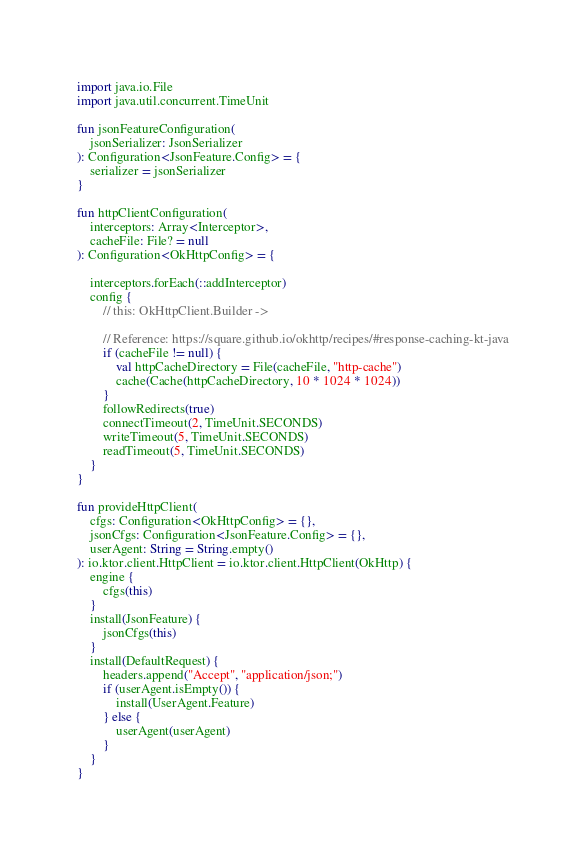Convert code to text. <code><loc_0><loc_0><loc_500><loc_500><_Kotlin_>import java.io.File
import java.util.concurrent.TimeUnit

fun jsonFeatureConfiguration(
    jsonSerializer: JsonSerializer
): Configuration<JsonFeature.Config> = {
    serializer = jsonSerializer
}

fun httpClientConfiguration(
    interceptors: Array<Interceptor>,
    cacheFile: File? = null
): Configuration<OkHttpConfig> = {

    interceptors.forEach(::addInterceptor)
    config {
        // this: OkHttpClient.Builder ->

        // Reference: https://square.github.io/okhttp/recipes/#response-caching-kt-java
        if (cacheFile != null) {
            val httpCacheDirectory = File(cacheFile, "http-cache")
            cache(Cache(httpCacheDirectory, 10 * 1024 * 1024))
        }
        followRedirects(true)
        connectTimeout(2, TimeUnit.SECONDS)
        writeTimeout(5, TimeUnit.SECONDS)
        readTimeout(5, TimeUnit.SECONDS)
    }
}

fun provideHttpClient(
    cfgs: Configuration<OkHttpConfig> = {},
    jsonCfgs: Configuration<JsonFeature.Config> = {},
    userAgent: String = String.empty()
): io.ktor.client.HttpClient = io.ktor.client.HttpClient(OkHttp) {
    engine {
        cfgs(this)
    }
    install(JsonFeature) {
        jsonCfgs(this)
    }
    install(DefaultRequest) {
        headers.append("Accept", "application/json;")
        if (userAgent.isEmpty()) {
            install(UserAgent.Feature)
        } else {
            userAgent(userAgent)
        }
    }
}
</code> 